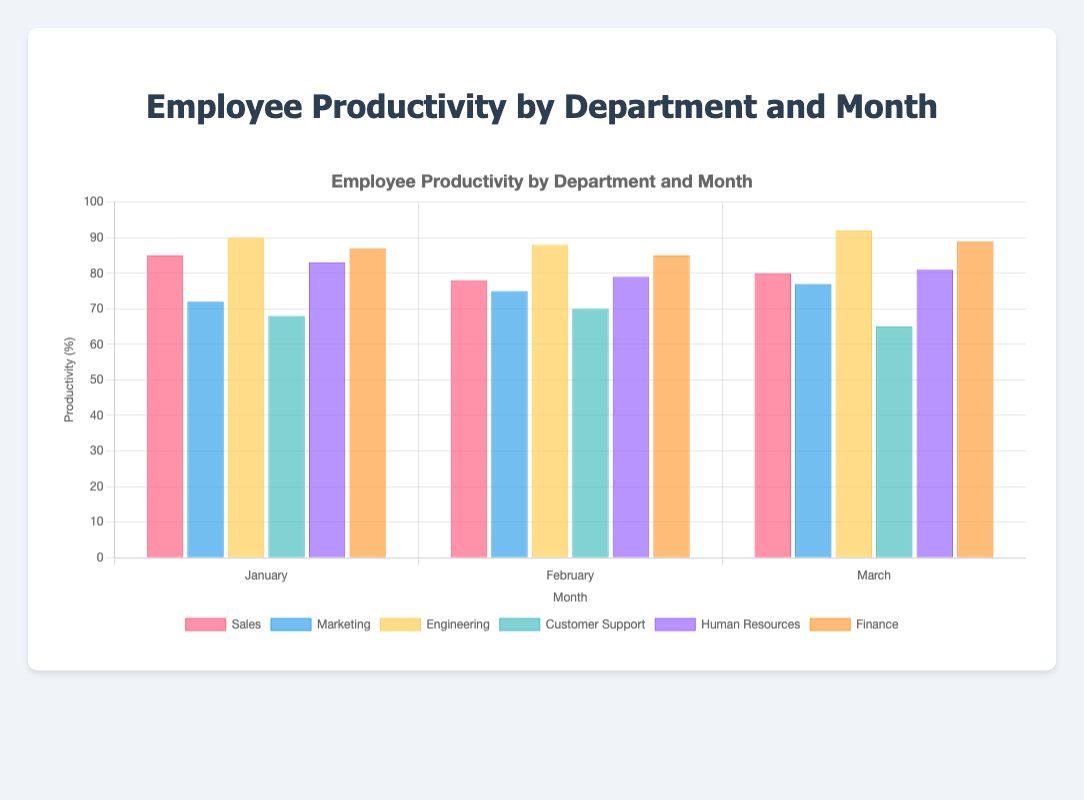Which department had the highest productivity in March? The highest productivity in March can be identified by looking at the tallest bar for March. The Engineering department has the highest productivity of 92% in March.
Answer: Engineering How does the productivity of Sales in January compare to its productivity in February? To compare the productivity, look at the height of the Sales bars in January and February. In January, the productivity is 85%, while in February, it is 78%. January's productivity is higher.
Answer: January is higher What is the average productivity of the Marketing department over the three months? Sum the productivities of Marketing for January (72%), February (75%), and March (77%), and divide by 3. The average is calculated as (72 + 75 + 77) / 3 = 74.67%.
Answer: 74.67% Which month did Customer Support have its lowest productivity, and what was the value? By looking at the height of the Customer Support bars, the lowest productivity is in March with a value of 65%.
Answer: March, 65% In February, which department's productivity was closest to 80%? Examine the bars for February. The Human Resources department has a productivity closest to 80%, with 79%.
Answer: Human Resources What is the total productivity for the Finance department across all three months? Sum the productivities of Finance for January (87%), February (85%), and March (89%). The total is 87 + 85 + 89 = 261%.
Answer: 261% Compare the productivity trend over the three months for Engineering and Finance. For Engineering, productivity is 90% in January, decreases to 88% in February, and then increases to 92% in March. For Finance, it is 87% in January, slightly decreases to 85% in February, and rises to 89% in March. Both departments end in March with higher productivity compared to February.
Answer: Both rise in March Which department showed a consistent increase in productivity over the three months? By examining the bars visually across all months, Marketing starts at 72% in January, increases to 75% in February, and further to 77% in March, showing a consistent increase.
Answer: Marketing What is the range of productivity for the Human Resources department from January to March? Find the highest and lowest productivity values for Human Resources. It's highest in March with 81% and lowest in February with 79%. The range is 81% - 79% = 2%.
Answer: 2% How does the productivity of Customer Support in January compare with Human Resources in the same month? Customer Support has a productivity of 68% in January, while Human Resources has 83%. Human Resources is higher by 83% - 68% = 15%.
Answer: Human Resources is higher by 15% 